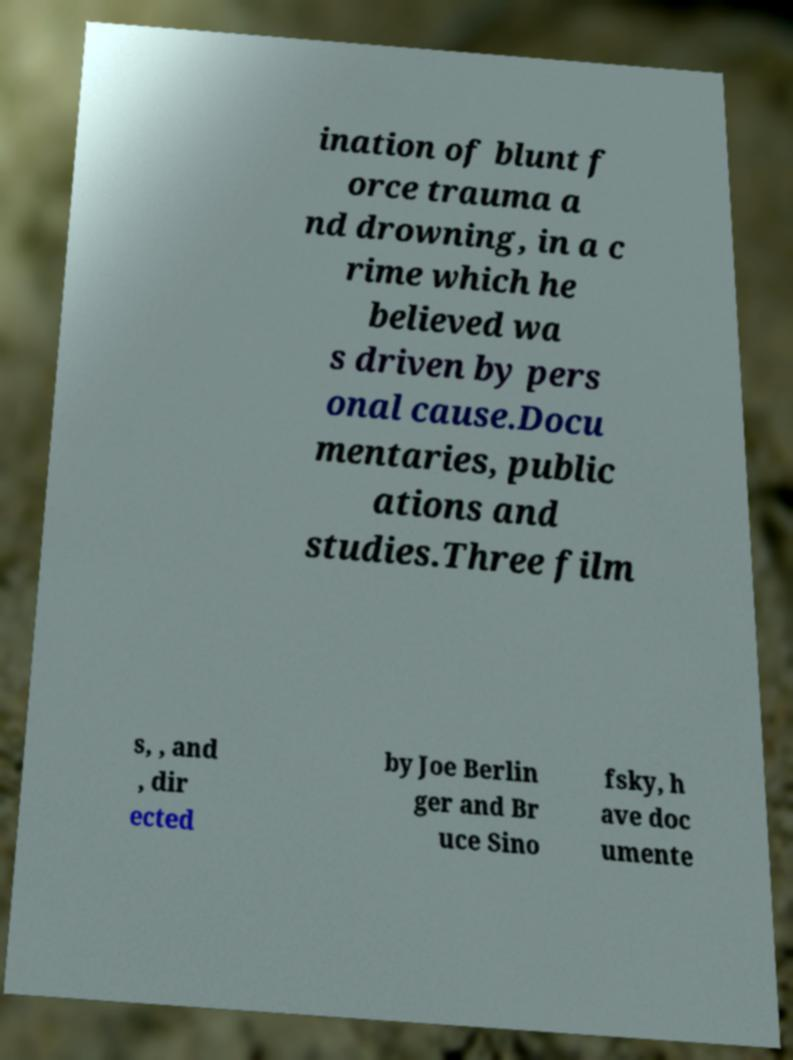Could you assist in decoding the text presented in this image and type it out clearly? ination of blunt f orce trauma a nd drowning, in a c rime which he believed wa s driven by pers onal cause.Docu mentaries, public ations and studies.Three film s, , and , dir ected by Joe Berlin ger and Br uce Sino fsky, h ave doc umente 